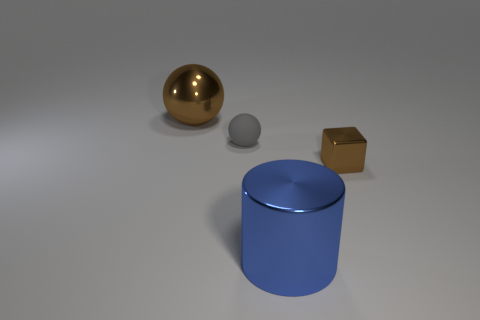What materials do the objects in the image seem to be made of? The objects in the image appear to be made from different materials. The sphere has a reflective, gold-like surface that suggests it might be metallic. The small sphere looks matte and could possibly be a clay or plastic material. The large cylinder has a smooth, metallic appearance, likely aluminum, and the cube seems to have a reflective gold finish similar to the large sphere. 